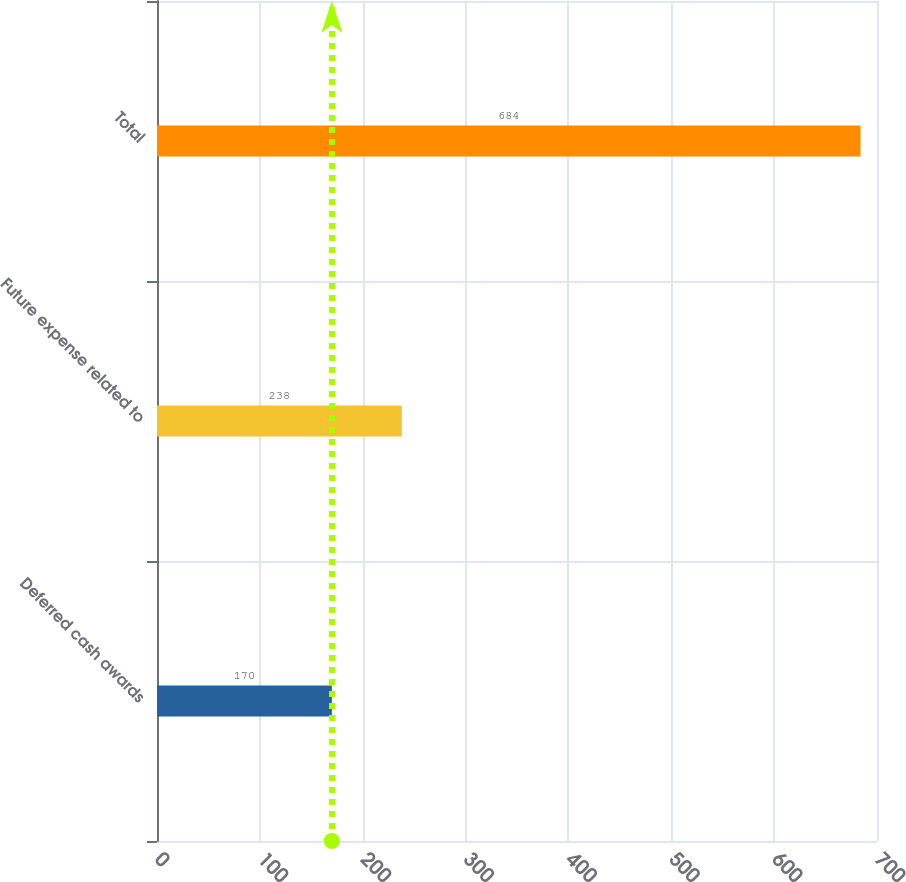Convert chart. <chart><loc_0><loc_0><loc_500><loc_500><bar_chart><fcel>Deferred cash awards<fcel>Future expense related to<fcel>Total<nl><fcel>170<fcel>238<fcel>684<nl></chart> 